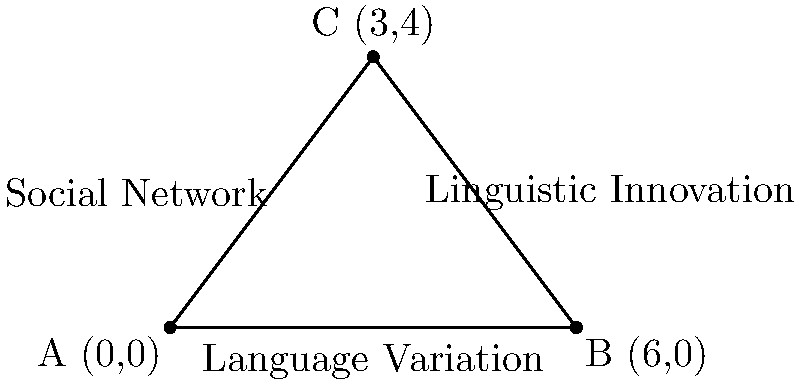In a sociolinguistic study, three factors are represented on a coordinate plane: Language Variation (x-axis), Social Network (y-axis), and Linguistic Innovation (z-axis, not shown). The points A(0,0), B(6,0), and C(3,4) form a triangle representing the relationship between these factors. Calculate the area of this triangle to determine the strength of the correlation between these sociolinguistic variables. To find the area of the triangle, we can use the formula:

Area = $\frac{1}{2}|x_1(y_2 - y_3) + x_2(y_3 - y_1) + x_3(y_1 - y_2)|$

Where $(x_1, y_1)$, $(x_2, y_2)$, and $(x_3, y_3)$ are the coordinates of the three points.

Given:
A(0,0), B(6,0), C(3,4)

Step 1: Substitute the coordinates into the formula:
Area = $\frac{1}{2}|0(0 - 4) + 6(4 - 0) + 3(0 - 0)|$

Step 2: Simplify:
Area = $\frac{1}{2}|0 + 24 + 0|$

Step 3: Calculate:
Area = $\frac{1}{2}(24) = 12$

Therefore, the area of the triangle is 12 square units, indicating a moderate to strong correlation between the three sociolinguistic factors.
Answer: 12 square units 